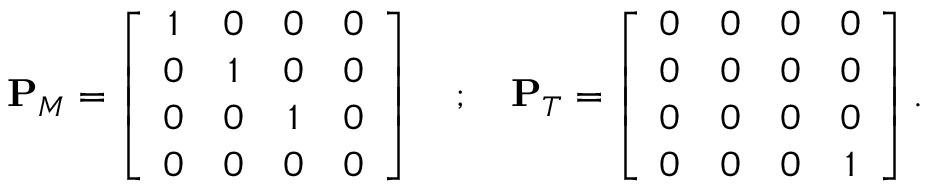Convert formula to latex. <formula><loc_0><loc_0><loc_500><loc_500>\begin{array} { r } { P _ { M } = \left [ \begin{array} { c c c c } { 1 } & { 0 } & { 0 } & { 0 } \\ { 0 } & { 1 } & { 0 } & { 0 } \\ { 0 } & { 0 } & { 1 } & { 0 } \\ { 0 } & { 0 } & { 0 } & { 0 } \end{array} \right ] ; P _ { T } = \left [ \begin{array} { c c c c } { 0 } & { 0 } & { 0 } & { 0 } \\ { 0 } & { 0 } & { 0 } & { 0 } \\ { 0 } & { 0 } & { 0 } & { 0 } \\ { 0 } & { 0 } & { 0 } & { 1 } \end{array} \right ] . } \end{array}</formula> 